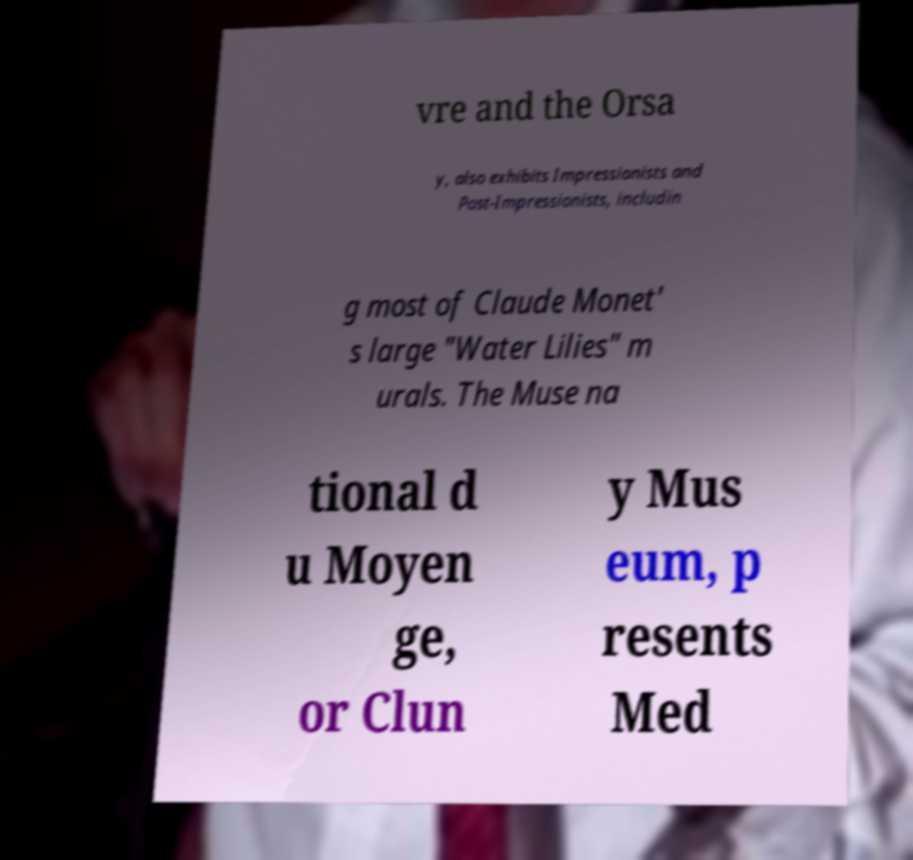Please read and relay the text visible in this image. What does it say? vre and the Orsa y, also exhibits Impressionists and Post-Impressionists, includin g most of Claude Monet' s large "Water Lilies" m urals. The Muse na tional d u Moyen ge, or Clun y Mus eum, p resents Med 